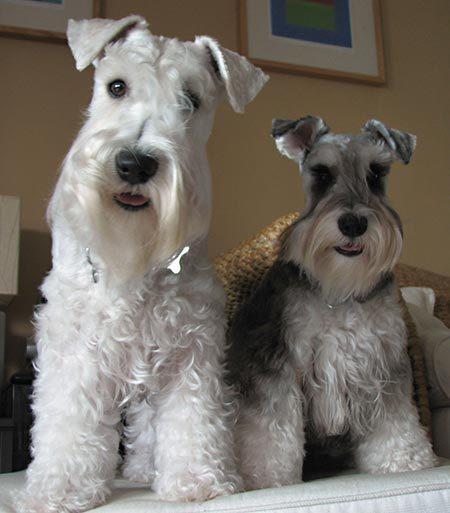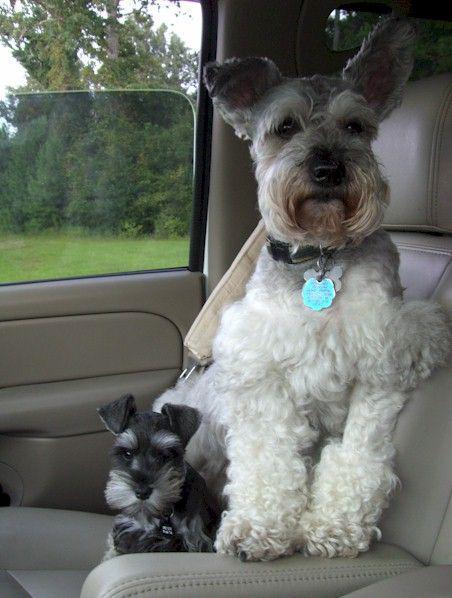The first image is the image on the left, the second image is the image on the right. Assess this claim about the two images: "Right image shows at least one schnauzer dog sitting in a car.". Correct or not? Answer yes or no. Yes. 